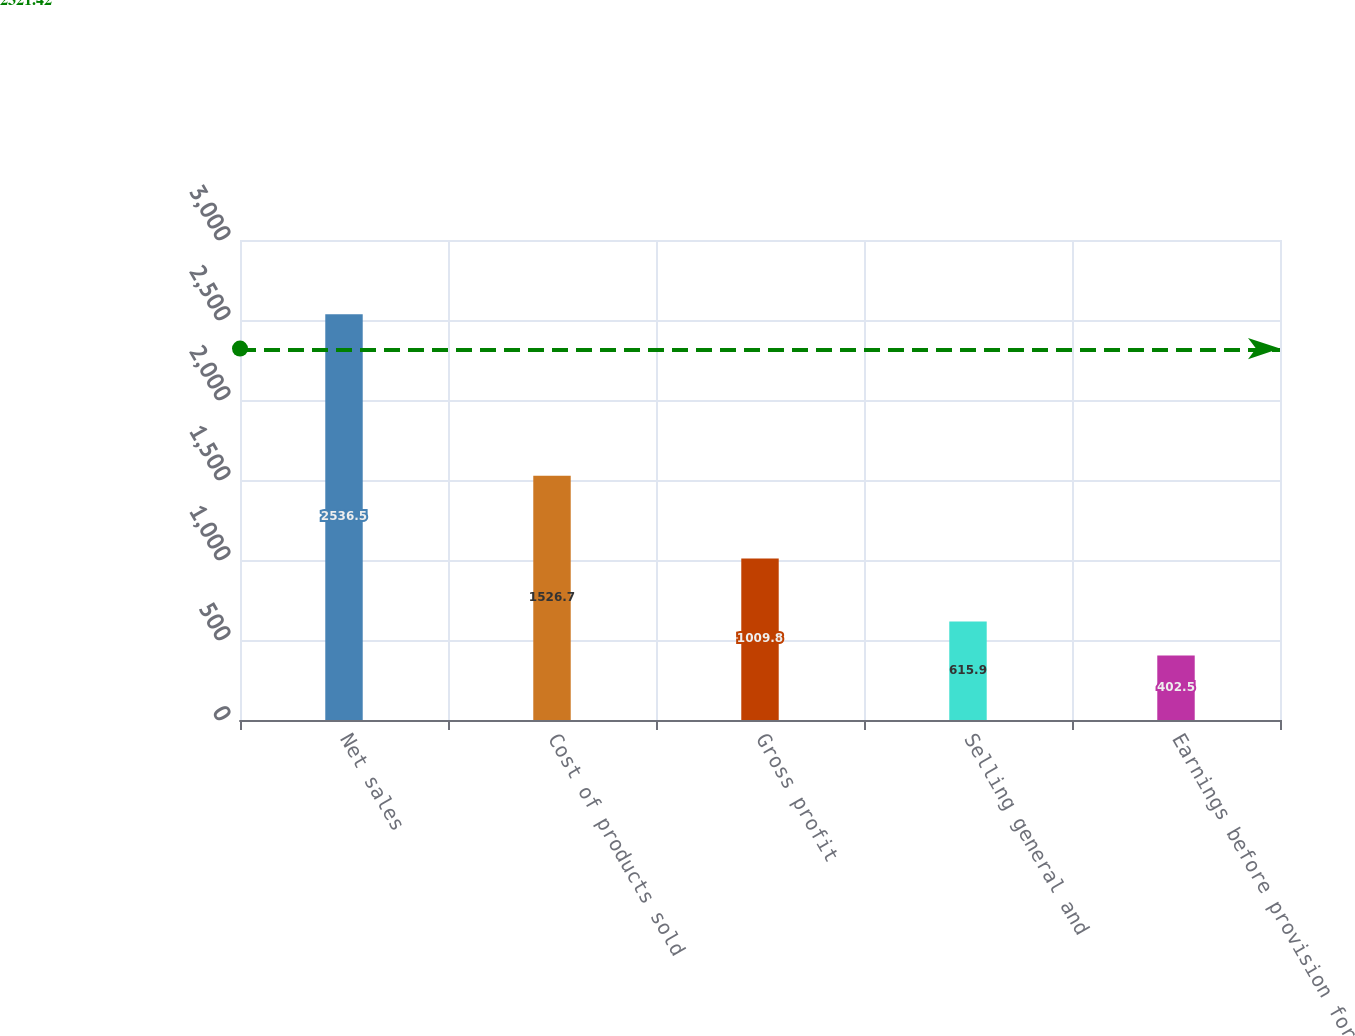Convert chart. <chart><loc_0><loc_0><loc_500><loc_500><bar_chart><fcel>Net sales<fcel>Cost of products sold<fcel>Gross profit<fcel>Selling general and<fcel>Earnings before provision for<nl><fcel>2536.5<fcel>1526.7<fcel>1009.8<fcel>615.9<fcel>402.5<nl></chart> 